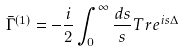Convert formula to latex. <formula><loc_0><loc_0><loc_500><loc_500>\bar { \Gamma } ^ { ( 1 ) } = - \frac { i } { 2 } \int _ { 0 } ^ { \infty } \frac { d s } { s } T r e ^ { i s \Delta }</formula> 